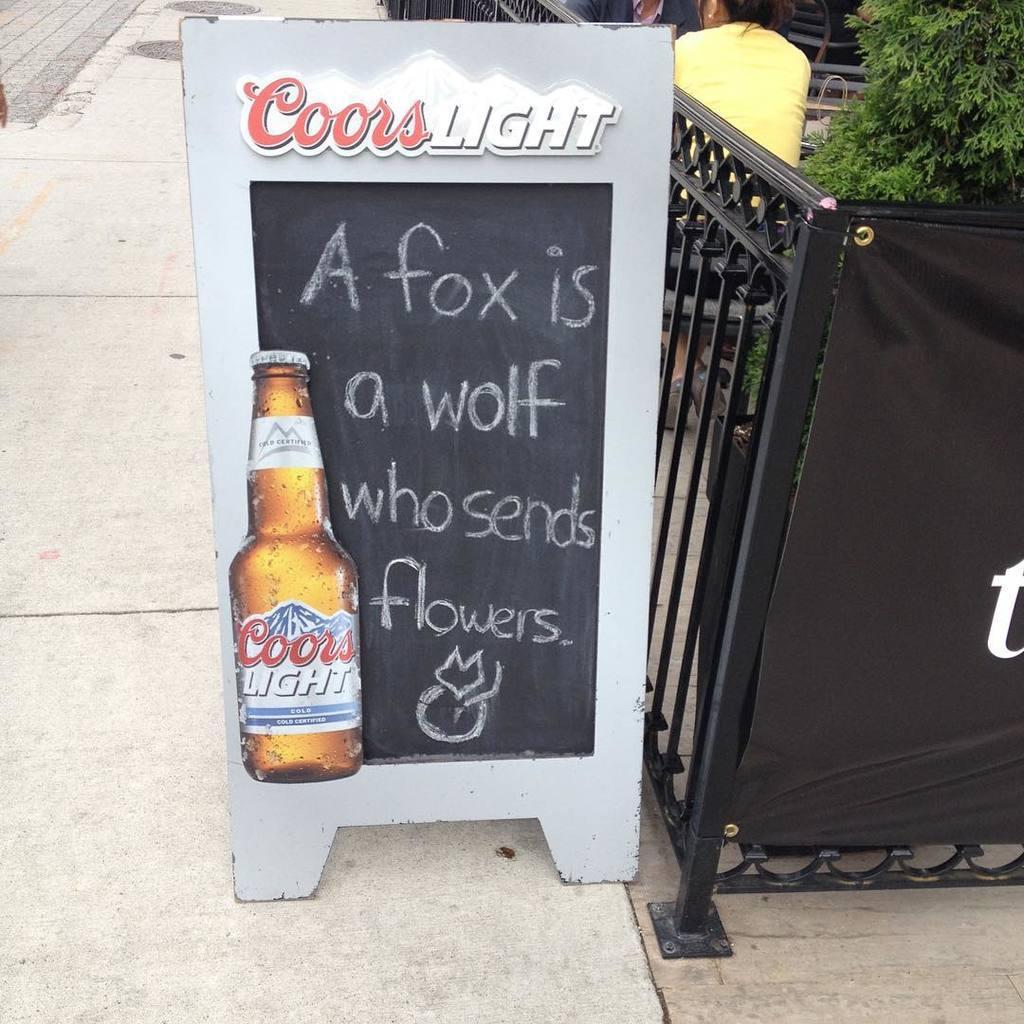How would you summarize this image in a sentence or two? In this image there is a board on the footpath. There is a gate on the right side. We can see a person on the right side. There is a tree on the right side. 